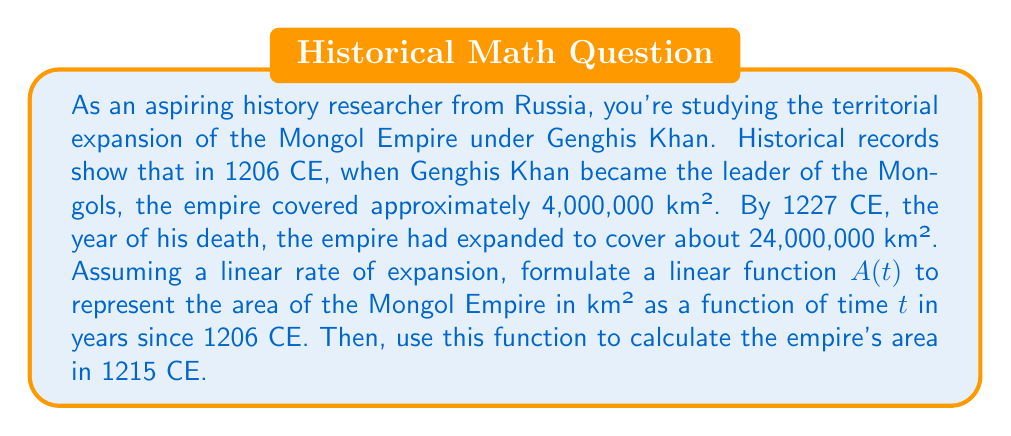Can you answer this question? Let's approach this step-by-step:

1) We need to formulate a linear function in the form $A(t) = mt + b$, where:
   $A(t)$ is the area of the empire in km²
   $t$ is the time in years since 1206 CE
   $m$ is the slope (rate of expansion)
   $b$ is the y-intercept (initial area in 1206 CE)

2) We know two points:
   - In 1206 CE (t = 0): Area = 4,000,000 km²
   - In 1227 CE (t = 21): Area = 24,000,000 km²

3) Let's calculate the slope (m):
   $$m = \frac{\text{change in area}}{\text{change in time}} = \frac{24,000,000 - 4,000,000}{21 - 0} = \frac{20,000,000}{21} \approx 952,380.95$$

4) The y-intercept (b) is the initial area: 4,000,000 km²

5) Therefore, our linear function is:
   $$A(t) = 952,380.95t + 4,000,000$$

6) To find the area in 1215 CE, we need to calculate A(9) since 1215 is 9 years after 1206:
   $$A(9) = 952,380.95 * 9 + 4,000,000 = 8,571,428.55 + 4,000,000 = 12,571,428.55$$
Answer: The linear function representing the Mongol Empire's expansion is $A(t) = 952,380.95t + 4,000,000$, where $A(t)$ is the area in km² and $t$ is years since 1206 CE. The empire's area in 1215 CE was approximately 12,571,429 km². 